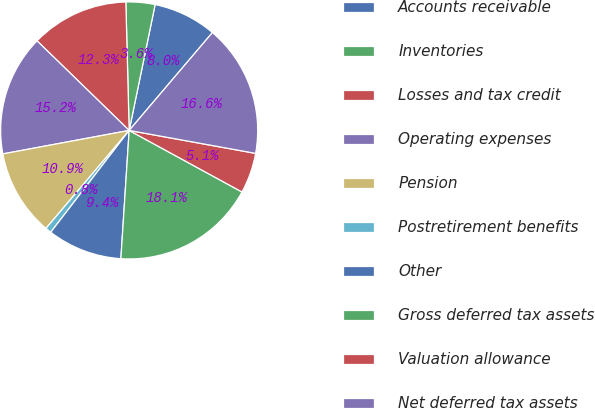<chart> <loc_0><loc_0><loc_500><loc_500><pie_chart><fcel>Accounts receivable<fcel>Inventories<fcel>Losses and tax credit<fcel>Operating expenses<fcel>Pension<fcel>Postretirement benefits<fcel>Other<fcel>Gross deferred tax assets<fcel>Valuation allowance<fcel>Net deferred tax assets<nl><fcel>7.98%<fcel>3.65%<fcel>12.31%<fcel>15.2%<fcel>10.87%<fcel>0.76%<fcel>9.42%<fcel>18.08%<fcel>5.09%<fcel>16.64%<nl></chart> 